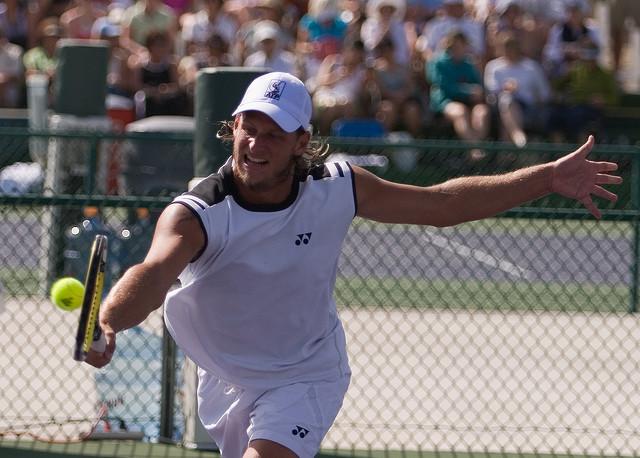Does this look like a tennis tournament?
Quick response, please. Yes. Is the woman holding a tennis ball?
Write a very short answer. No. What is in the forefront of the picture?
Keep it brief. Tennis ball. What brand of clothing is her outfit?
Give a very brief answer. Nike. What color is the hat the girl is wearing?
Be succinct. White. Does this man have enough leverage to hit the ball a long distance?
Write a very short answer. No. Which hand holds the racket?
Short answer required. Right. 